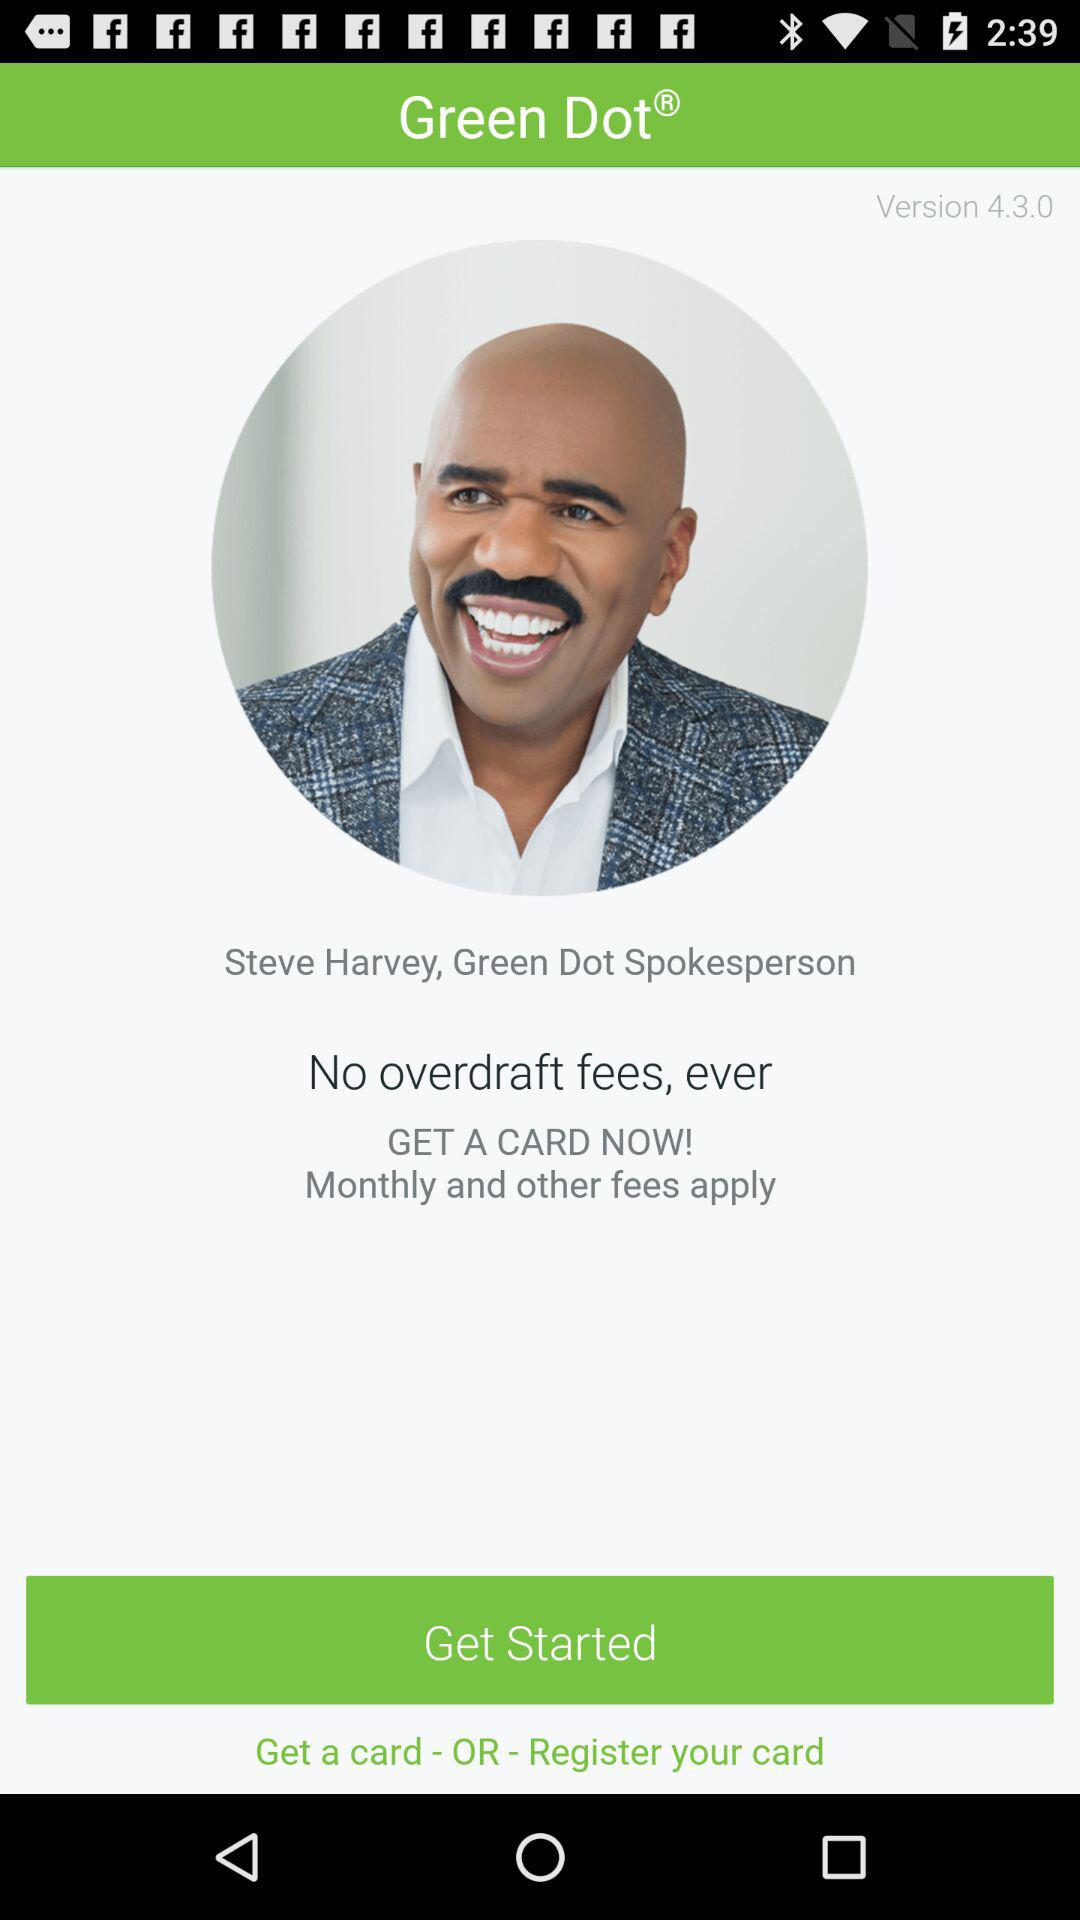Who is the spokesperson? The spokesperson is Steve Harvey. 